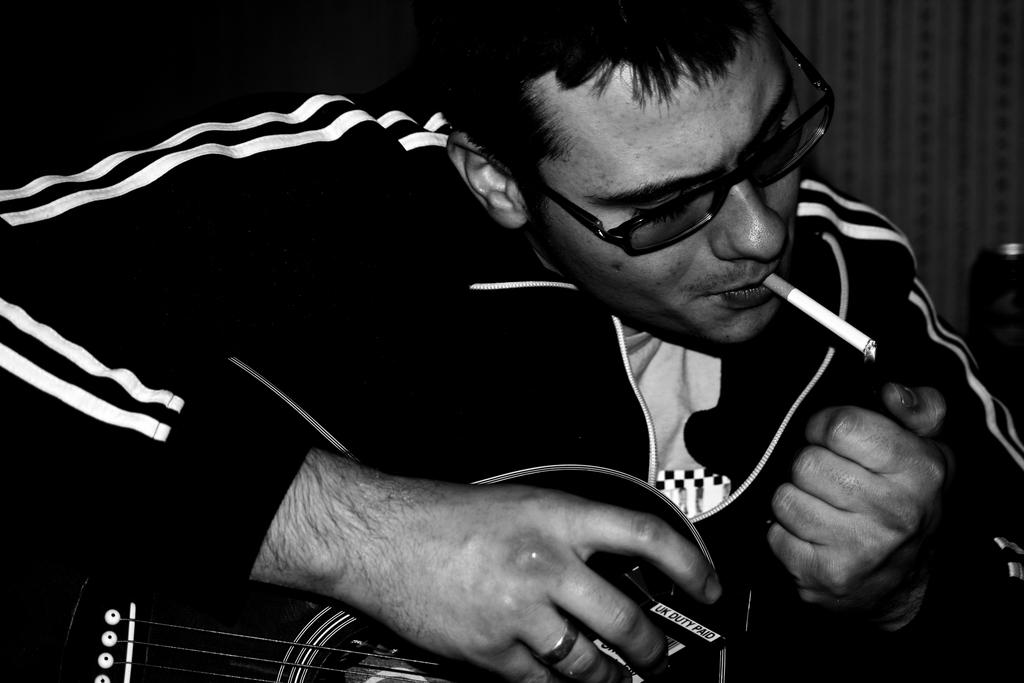What is the person holding in their mouth in the image? The person has a cigarette in their mouth. What accessory is the person wearing in the image? The person is wearing spectacles. What musical instrument is the person holding in the image? The person is holding a guitar. What object is the person holding in their hand, other than the guitar? The person is holding a box. How many boats can be seen in the image? There are no boats present in the image. What type of geese are visible in the image? There are no geese present in the image. 